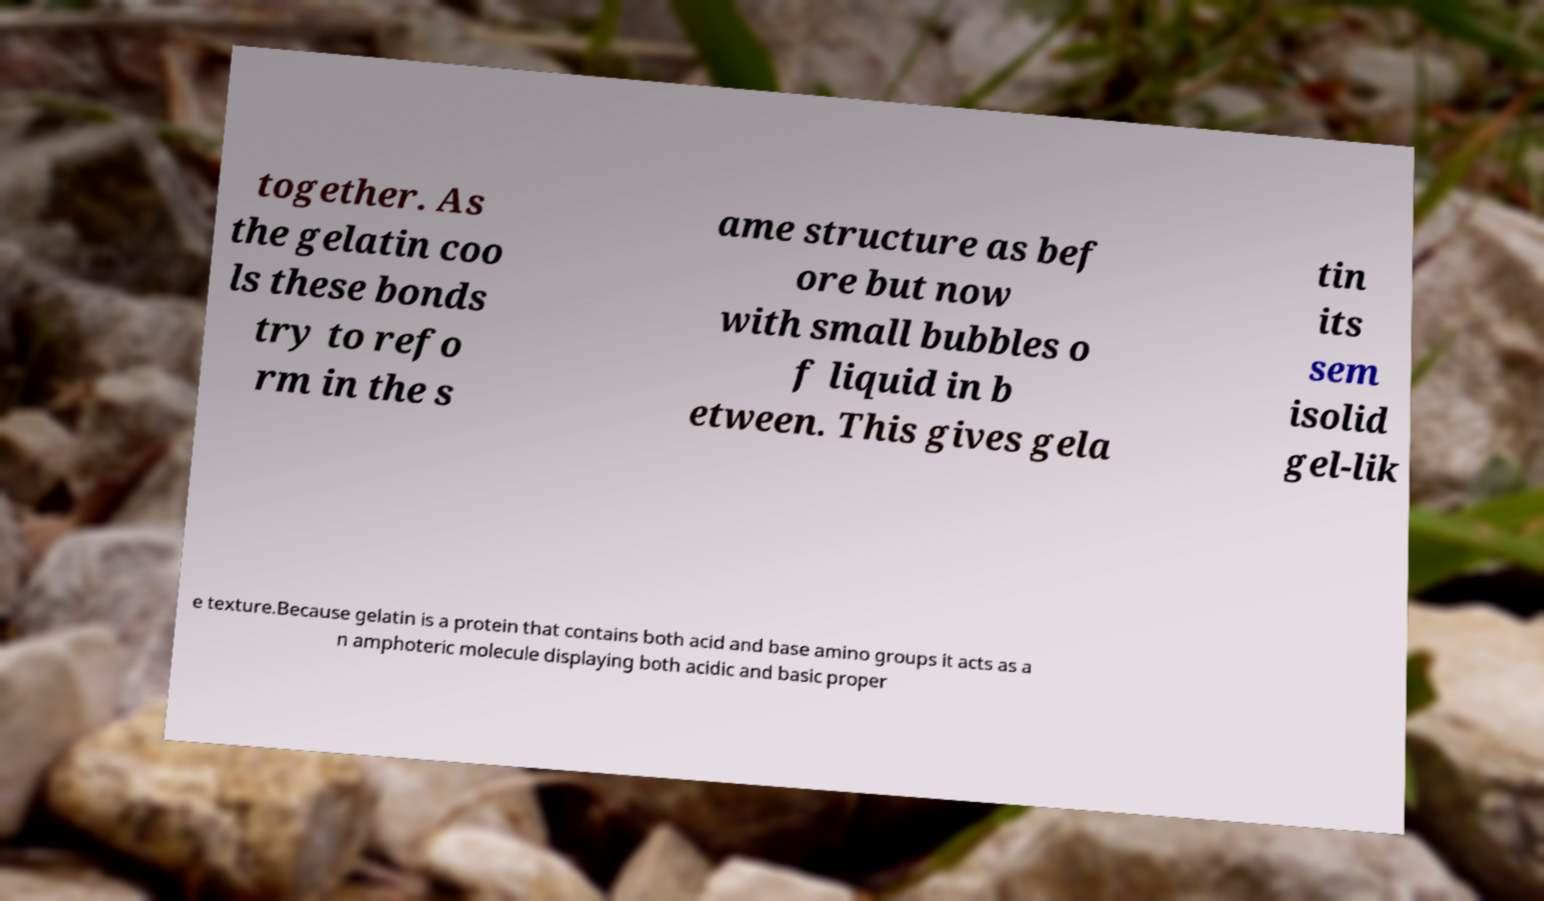Could you assist in decoding the text presented in this image and type it out clearly? together. As the gelatin coo ls these bonds try to refo rm in the s ame structure as bef ore but now with small bubbles o f liquid in b etween. This gives gela tin its sem isolid gel-lik e texture.Because gelatin is a protein that contains both acid and base amino groups it acts as a n amphoteric molecule displaying both acidic and basic proper 